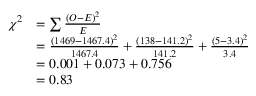Convert formula to latex. <formula><loc_0><loc_0><loc_500><loc_500>{ \begin{array} { r l } { \chi ^ { 2 } } & { = \sum { \frac { ( O - E ) ^ { 2 } } { E } } } \\ & { = { \frac { ( 1 4 6 9 - 1 4 6 7 . 4 ) ^ { 2 } } { 1 4 6 7 . 4 } } + { \frac { ( 1 3 8 - 1 4 1 . 2 ) ^ { 2 } } { 1 4 1 . 2 } } + { \frac { ( 5 - 3 . 4 ) ^ { 2 } } { 3 . 4 } } } \\ & { = 0 . 0 0 1 + 0 . 0 7 3 + 0 . 7 5 6 } \\ & { = 0 . 8 3 } \end{array} }</formula> 